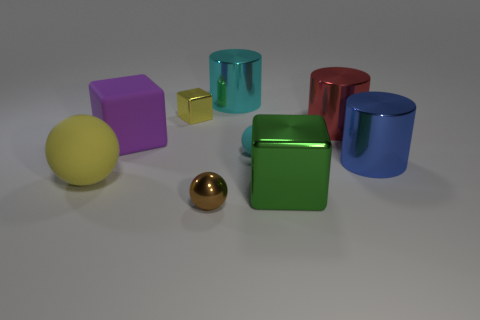Add 1 small balls. How many objects exist? 10 Subtract all red cylinders. How many cylinders are left? 2 Subtract all big blocks. How many blocks are left? 1 Subtract 0 blue blocks. How many objects are left? 9 Subtract all cubes. How many objects are left? 6 Subtract 2 cubes. How many cubes are left? 1 Subtract all purple cylinders. Subtract all purple balls. How many cylinders are left? 3 Subtract all yellow cubes. How many green cylinders are left? 0 Subtract all big red things. Subtract all big objects. How many objects are left? 2 Add 5 large green objects. How many large green objects are left? 6 